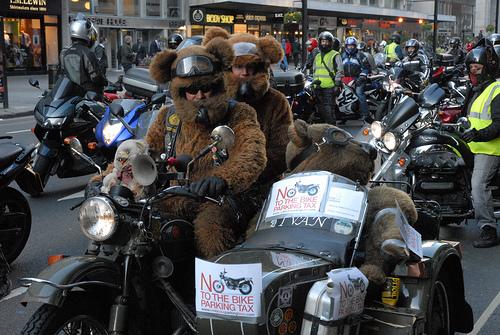How many bears are in the picture?
Keep it brief. 3. What color are the peoples' suits?
Be succinct. Brown. What does it say on the front of the bikes?
Short answer required. No to bike parking tax. What are these people riding?
Be succinct. Motorcycle. Are those real bears?
Short answer required. No. Who are riding the bikes?
Write a very short answer. Men. 